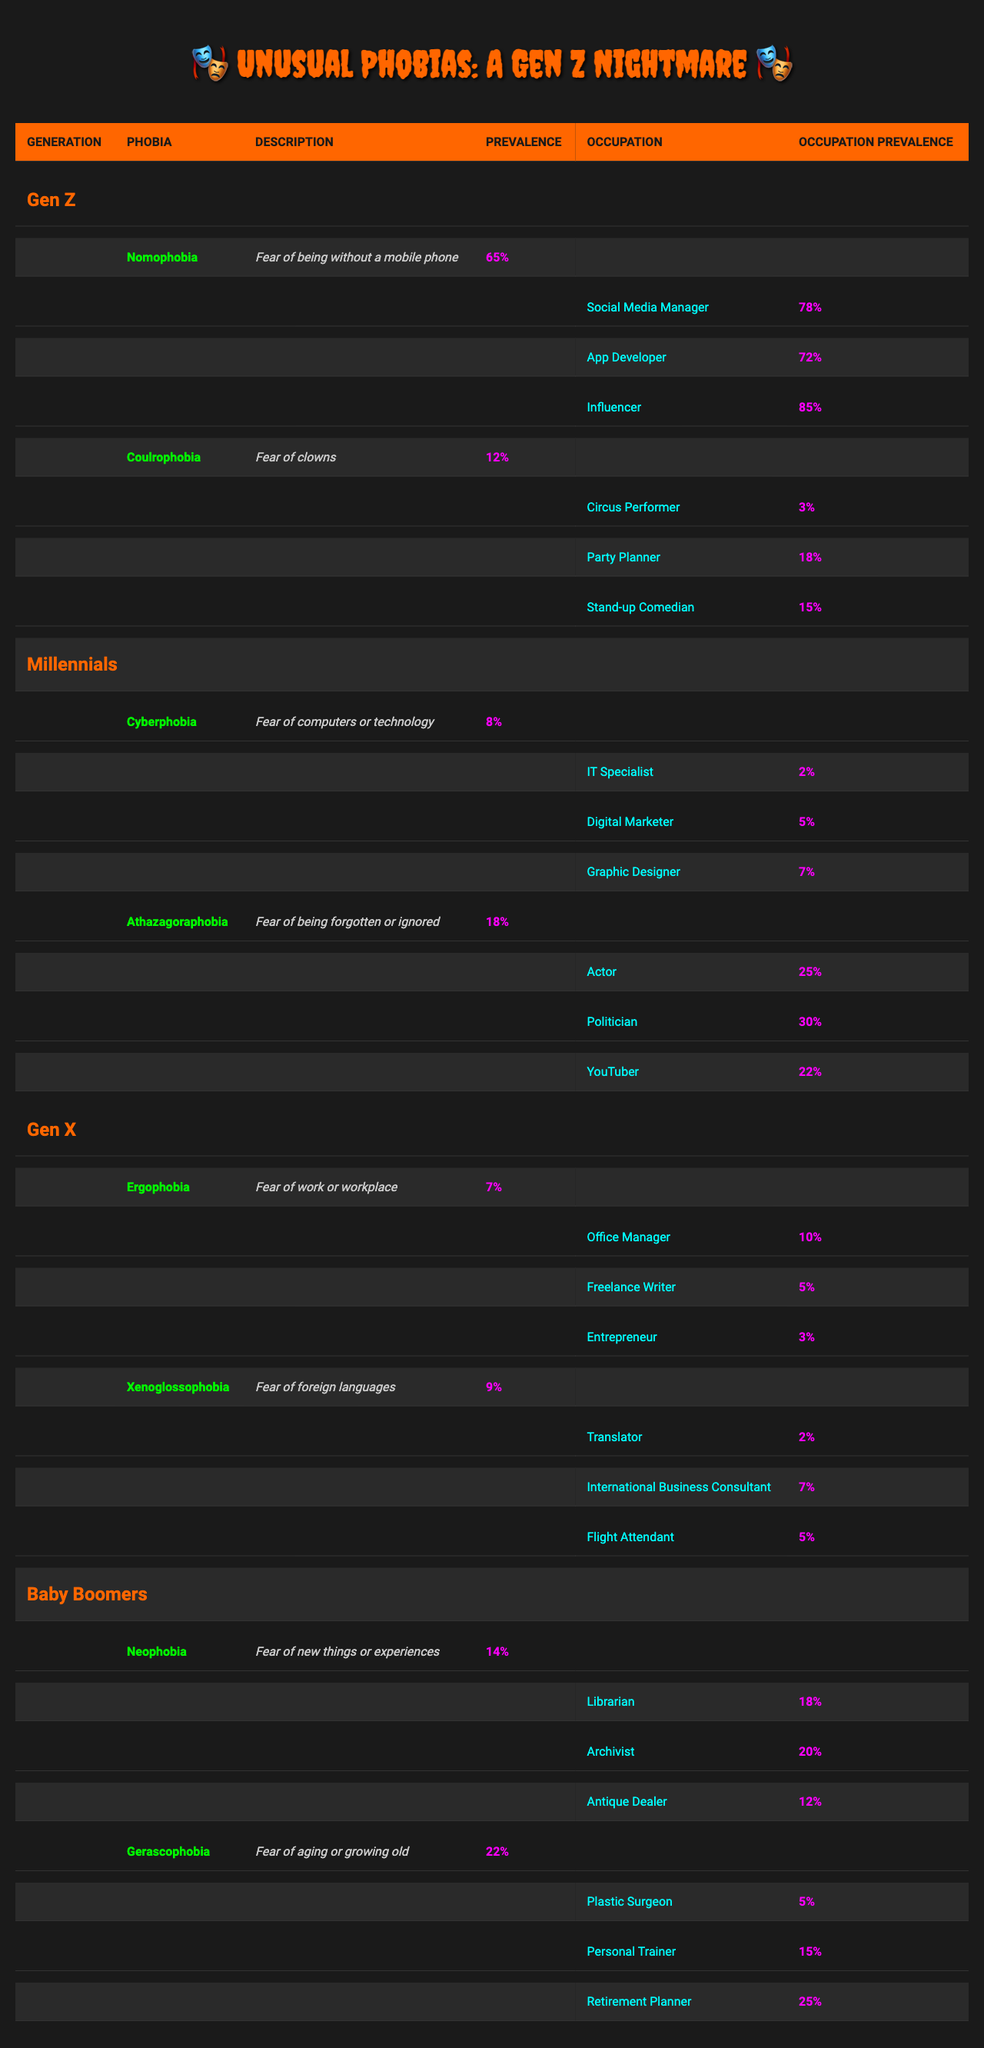What is the prevalence of Nomophobia among Gen Z? The table shows that Nomophobia has a prevalence of 65% in Gen Z.
Answer: 65% Which phobia has the highest prevalence among Gen Z occupations? The highest prevalence among Gen Z occupations is for Influencers at 85%.
Answer: 85% What is the average prevalence of phobias for Millennials? The phobia prevalence for Millennials is 8% (Cyberphobia) and 18% (Athazagoraphobia). To find the average: (8 + 18) / 2 = 13.
Answer: 13% Is Ergophobia more prevalent among Gen X or Millennials? The table shows Ergophobia with a prevalence of 7% in Gen X and there is no data for it in Millennials, indicating that it is more prevalent in Gen X.
Answer: Yes Which generation has the highest average phobia prevalence? Calculate the average for each generation: Gen Z: (65 + 12) / 2 = 38.5, Millennials: (8 + 18) / 2 = 13, Gen X: (7 + 9) / 2 = 8, Baby Boomers: (14 + 22) / 2 = 18. The highest average per generation is 38.5 for Gen Z.
Answer: Gen Z What is the total prevalence of phobias among Baby Boomers? The phobias are Neophobia (14%) and Gerascophobia (22%). Adding them gives: 14 + 22 = 36.
Answer: 36% Does any occupation in Gen Z have a higher prevalence of phobia than the average prevalence of phobias in Boomers? The average prevalence of Baby Boomers is 18%. The Influencer occupation in Gen Z has a prevalence of 85%, which is higher than 18%.
Answer: Yes What is the lowest prevalence of phobia recorded in the table for any occupation? The lowest occupation prevalence recorded is for the Knight (Ergophobia) in Gen X at 3%.
Answer: 3% Based on the data, can we say that the fear of being forgotten is more prevalent than the fear of clowns in Millennials? Athazagoraphobia has a prevalence of 18% in Millennials, while Coulrophobia in Gen Z, which impacts Millennials as well, is at 12%. So yes, it is more prevalent.
Answer: Yes How does the prevalence of Cyberphobia in Millennials compare with Nomophobia in Gen Z? Cyberphobia has a prevalence of 8% in Millennials while Nomophobia has a higher prevalence of 65% in Gen Z. So, Nomophobia is significantly higher.
Answer: Higher 